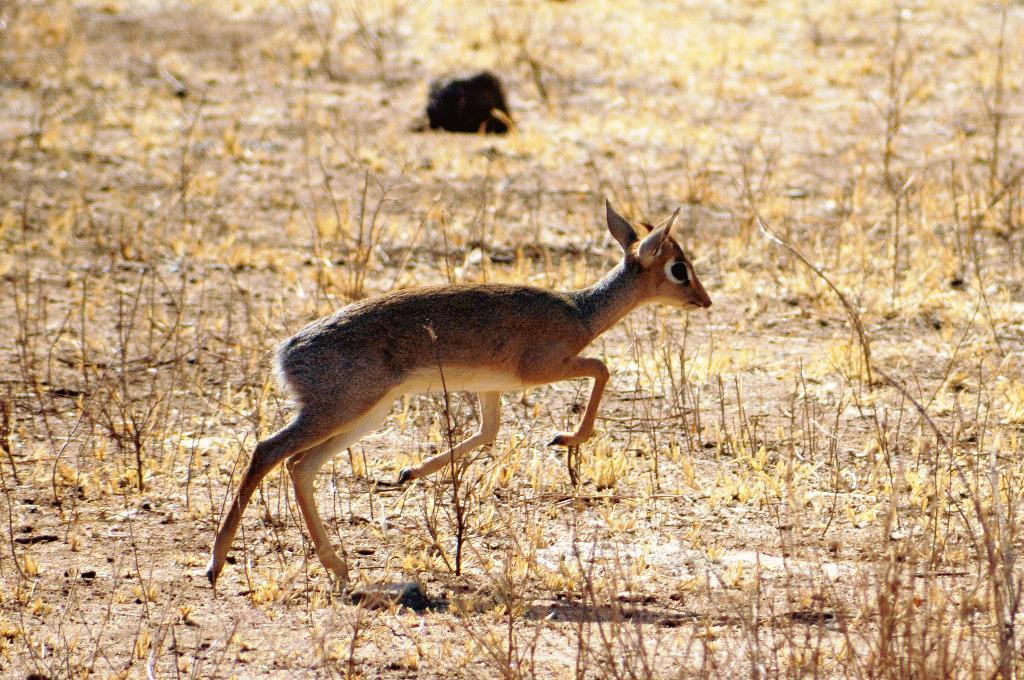What animal can be seen in the image? There is a deer in the image. What is the deer doing in the image? The deer is running. What type of vegetation is visible in the image? There is dried grass visible in the image. What type of bit is the deer holding in its mouth in the image? There is no bit present in the image, as the deer is not a horse or any other animal that would use a bit. 